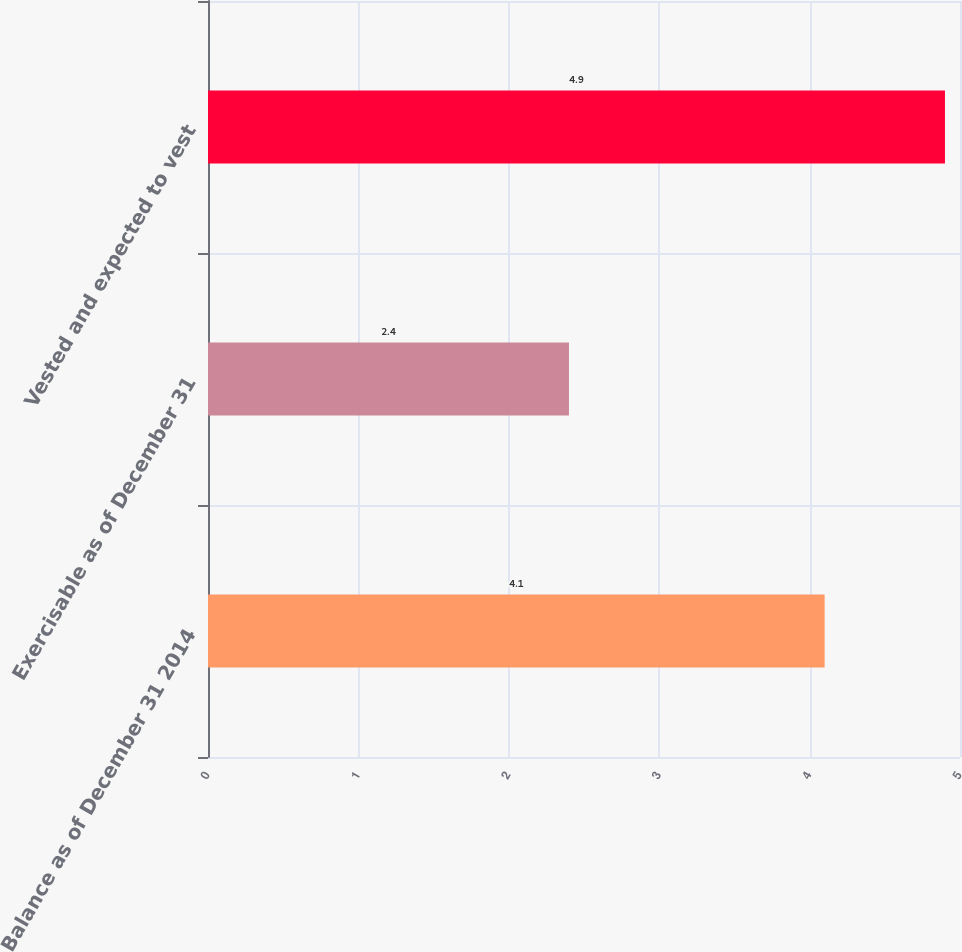Convert chart to OTSL. <chart><loc_0><loc_0><loc_500><loc_500><bar_chart><fcel>Balance as of December 31 2014<fcel>Exercisable as of December 31<fcel>Vested and expected to vest<nl><fcel>4.1<fcel>2.4<fcel>4.9<nl></chart> 